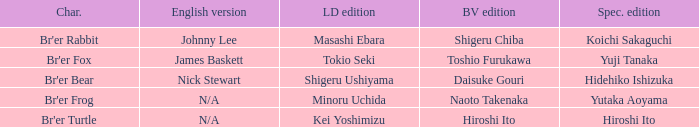Who is the character where the special edition is koichi sakaguchi? Br'er Rabbit. 